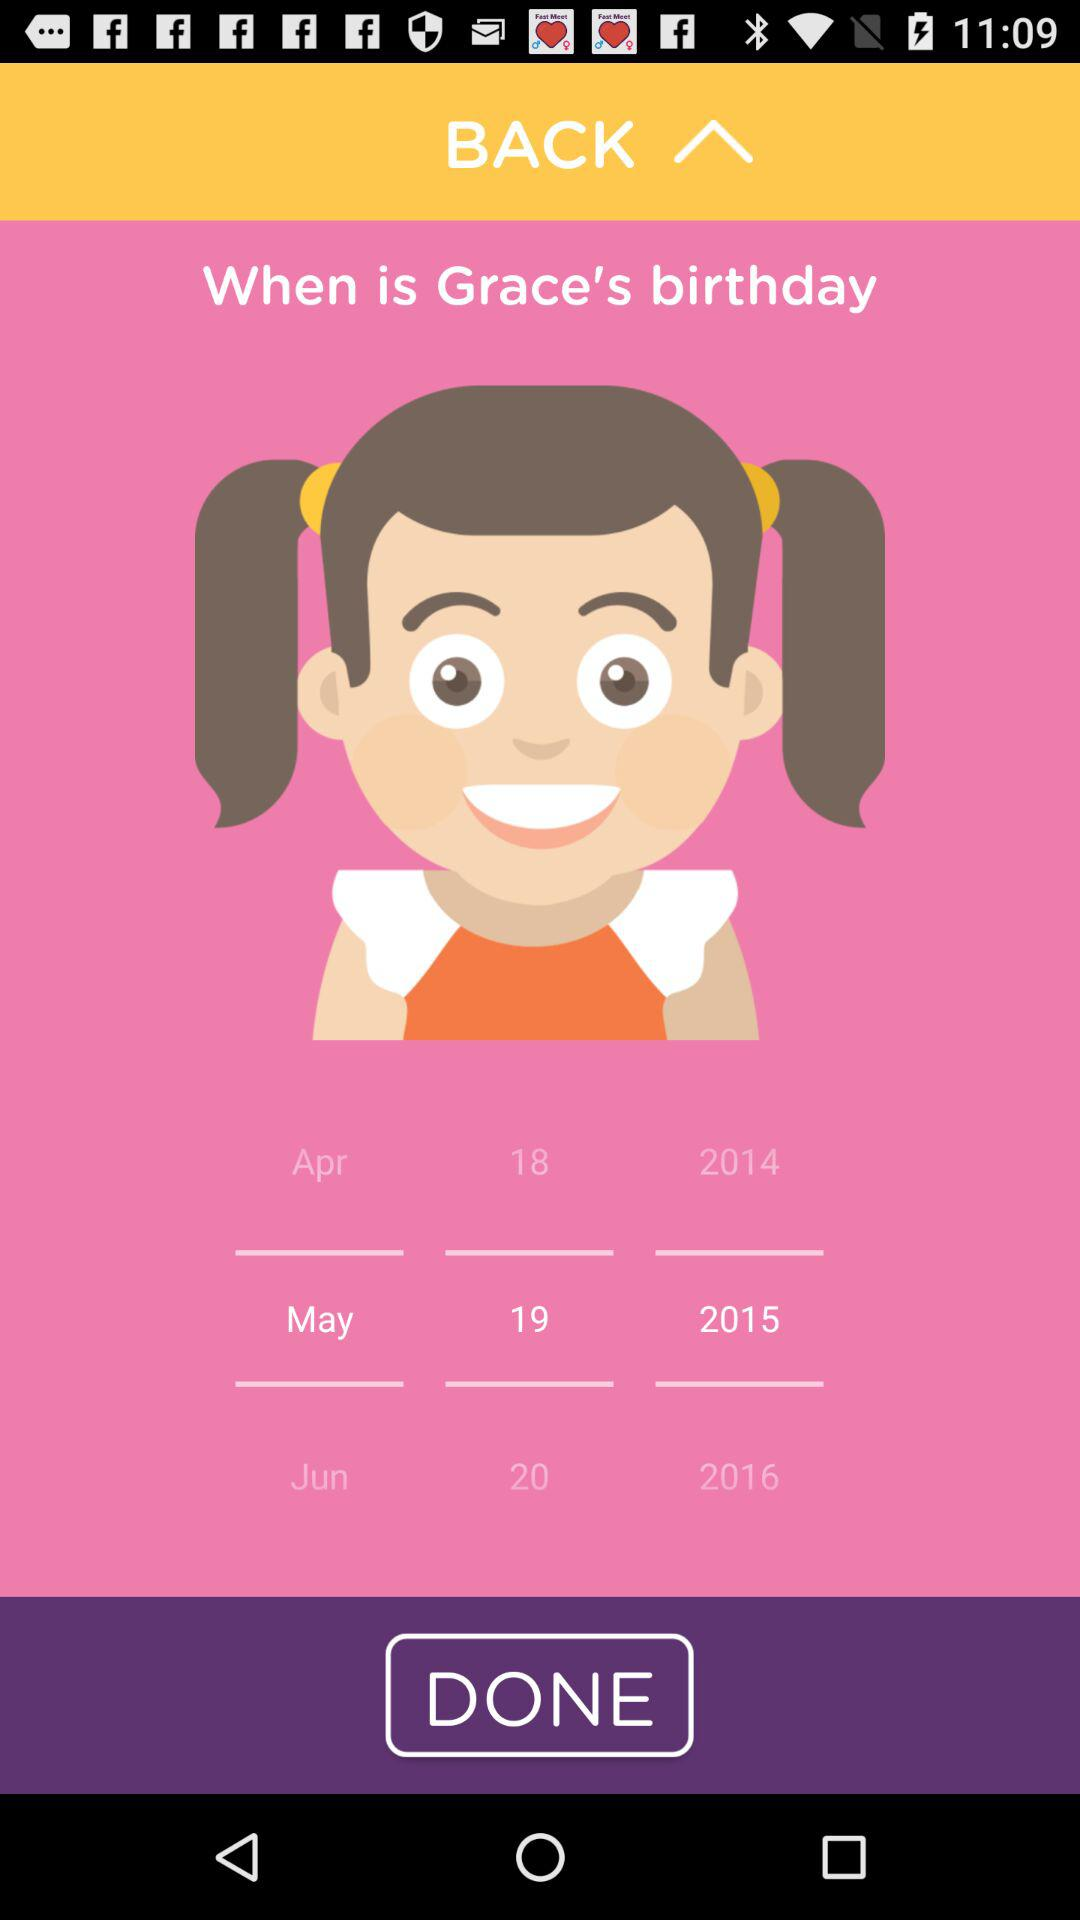How many years are between the oldest and youngest birthday options?
Answer the question using a single word or phrase. 2 